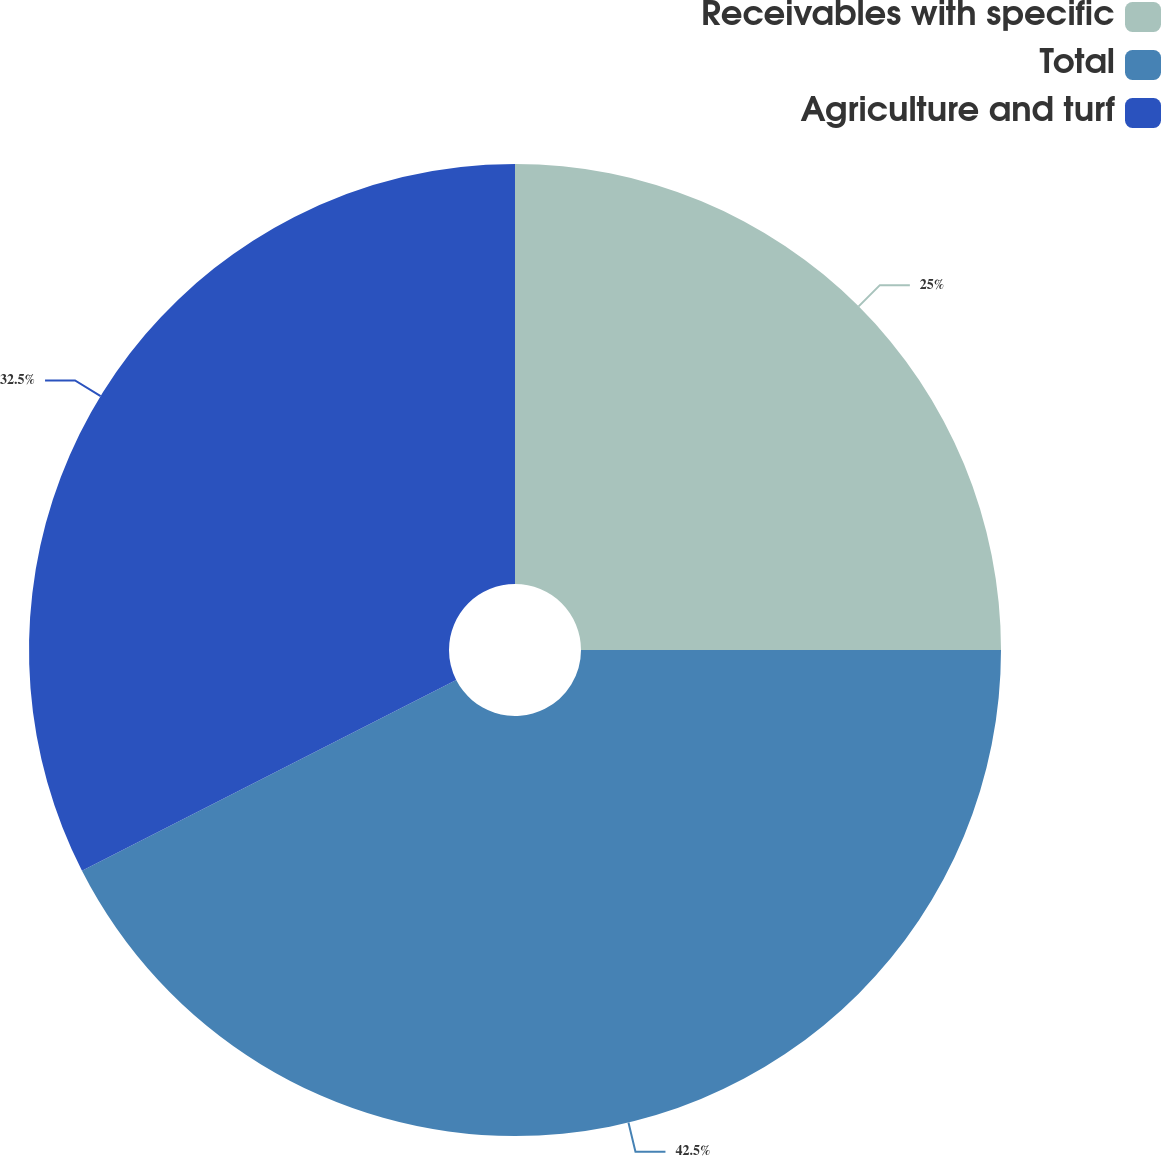Convert chart. <chart><loc_0><loc_0><loc_500><loc_500><pie_chart><fcel>Receivables with specific<fcel>Total<fcel>Agriculture and turf<nl><fcel>25.0%<fcel>42.5%<fcel>32.5%<nl></chart> 